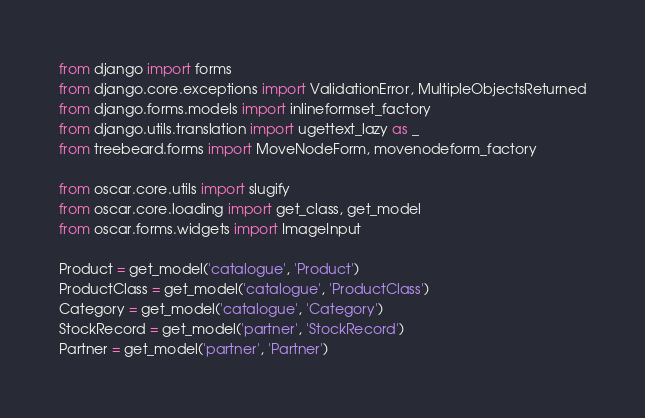Convert code to text. <code><loc_0><loc_0><loc_500><loc_500><_Python_>from django import forms
from django.core.exceptions import ValidationError, MultipleObjectsReturned
from django.forms.models import inlineformset_factory
from django.utils.translation import ugettext_lazy as _
from treebeard.forms import MoveNodeForm, movenodeform_factory

from oscar.core.utils import slugify
from oscar.core.loading import get_class, get_model
from oscar.forms.widgets import ImageInput

Product = get_model('catalogue', 'Product')
ProductClass = get_model('catalogue', 'ProductClass')
Category = get_model('catalogue', 'Category')
StockRecord = get_model('partner', 'StockRecord')
Partner = get_model('partner', 'Partner')</code> 